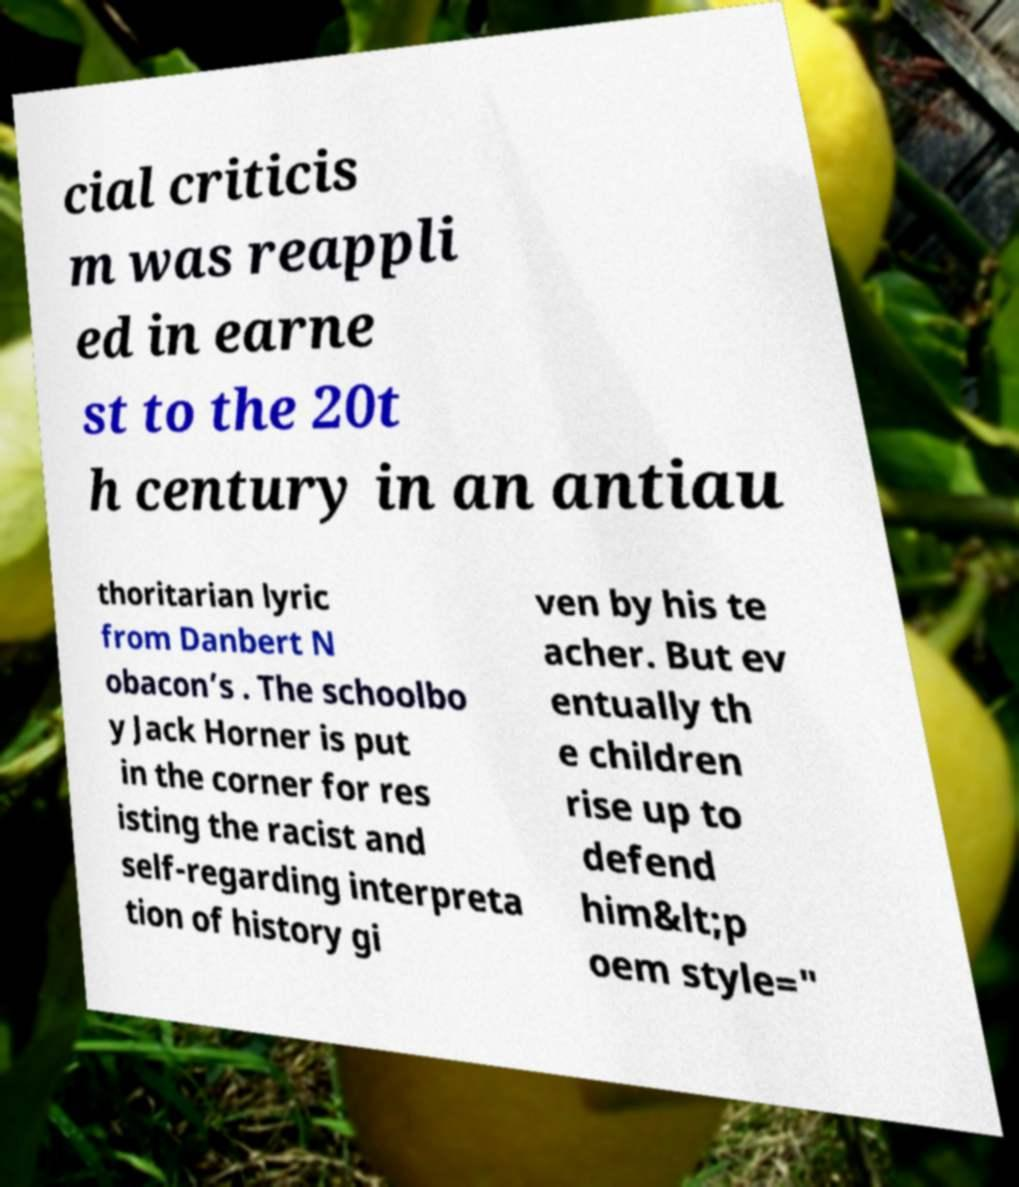I need the written content from this picture converted into text. Can you do that? cial criticis m was reappli ed in earne st to the 20t h century in an antiau thoritarian lyric from Danbert N obacon’s . The schoolbo y Jack Horner is put in the corner for res isting the racist and self-regarding interpreta tion of history gi ven by his te acher. But ev entually th e children rise up to defend him&lt;p oem style=" 